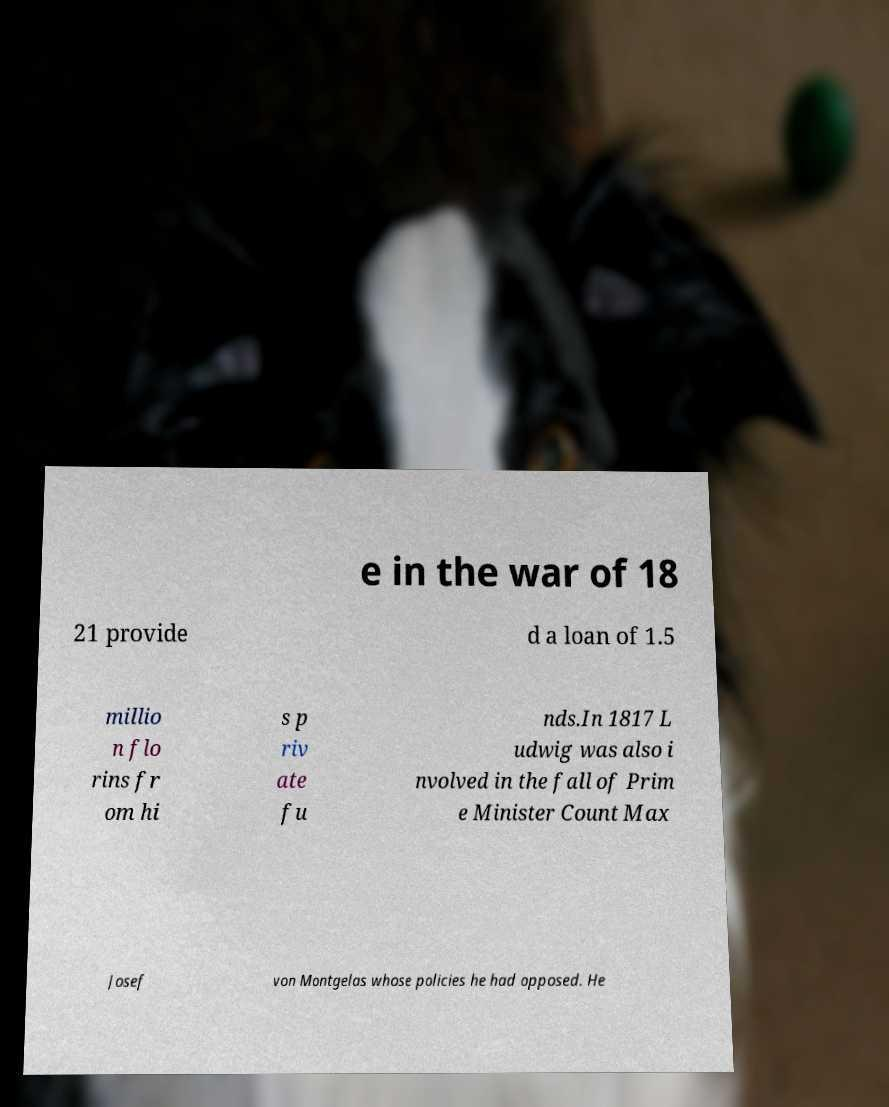Could you extract and type out the text from this image? e in the war of 18 21 provide d a loan of 1.5 millio n flo rins fr om hi s p riv ate fu nds.In 1817 L udwig was also i nvolved in the fall of Prim e Minister Count Max Josef von Montgelas whose policies he had opposed. He 